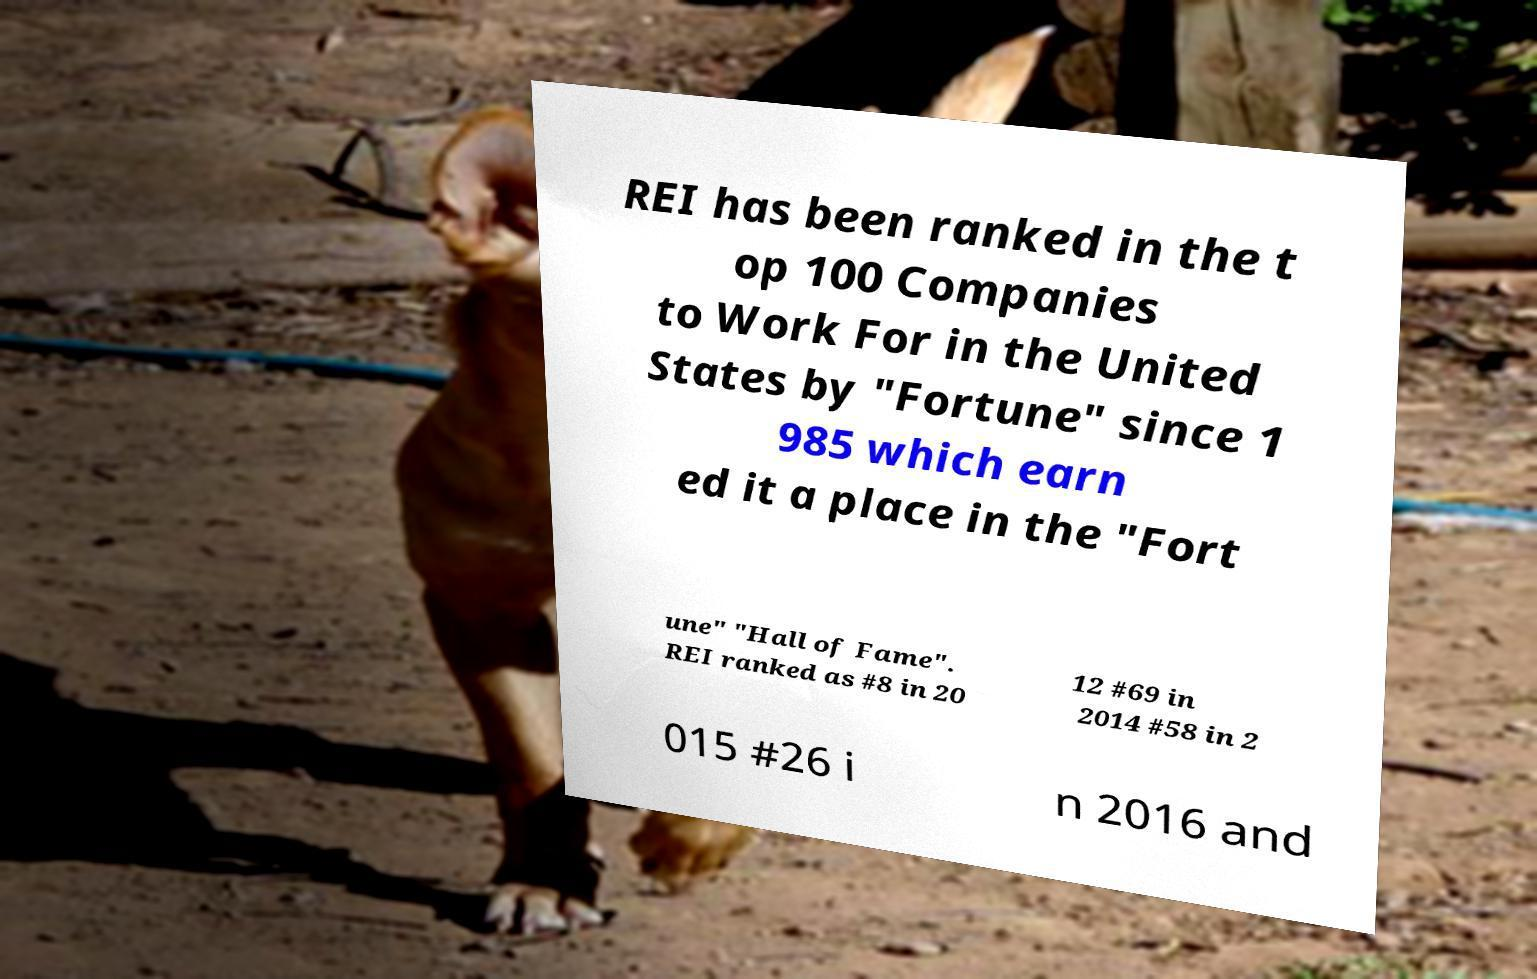There's text embedded in this image that I need extracted. Can you transcribe it verbatim? REI has been ranked in the t op 100 Companies to Work For in the United States by "Fortune" since 1 985 which earn ed it a place in the "Fort une" "Hall of Fame". REI ranked as #8 in 20 12 #69 in 2014 #58 in 2 015 #26 i n 2016 and 